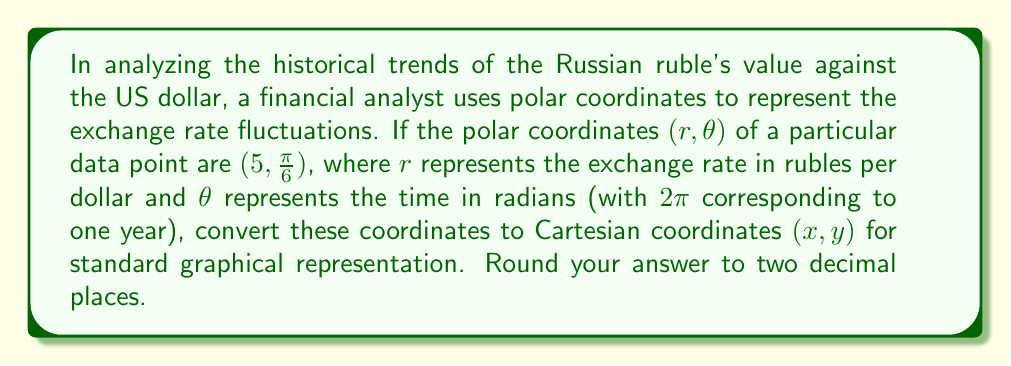Could you help me with this problem? To convert polar coordinates $(r, \theta)$ to Cartesian coordinates $(x, y)$, we use the following formulas:

$$ x = r \cos(\theta) $$
$$ y = r \sin(\theta) $$

Given:
$r = 5$ (rubles per dollar)
$\theta = \frac{\pi}{6}$ radians

Let's calculate x:
$$ x = 5 \cos(\frac{\pi}{6}) $$
$$ x = 5 \cdot \frac{\sqrt{3}}{2} $$
$$ x \approx 4.33 $$

Now, let's calculate y:
$$ y = 5 \sin(\frac{\pi}{6}) $$
$$ y = 5 \cdot \frac{1}{2} $$
$$ y = 2.5 $$

In this context, x represents the horizontal component of the exchange rate fluctuation, which could be interpreted as the rate's deviation from a baseline value. The y component represents the vertical displacement, which could be viewed as the time progression within the year (since $2\pi$ represents a full year).
Answer: $(4.33, 2.50)$ 